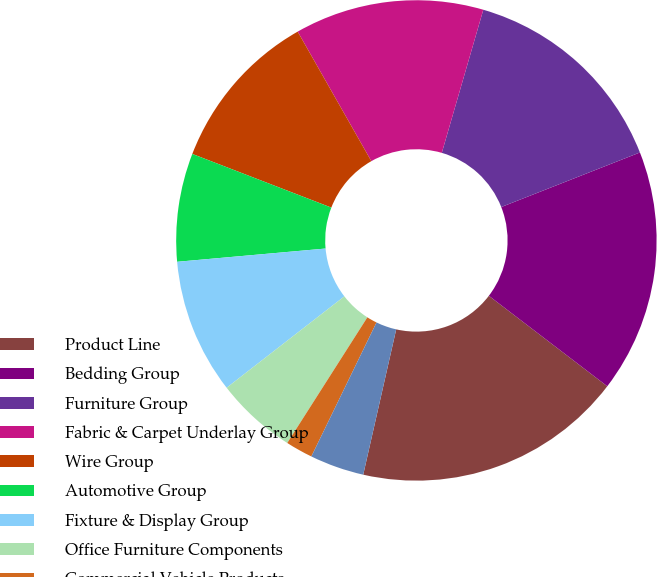Convert chart. <chart><loc_0><loc_0><loc_500><loc_500><pie_chart><fcel>Product Line<fcel>Bedding Group<fcel>Furniture Group<fcel>Fabric & Carpet Underlay Group<fcel>Wire Group<fcel>Automotive Group<fcel>Fixture & Display Group<fcel>Office Furniture Components<fcel>Commercial Vehicle Products<fcel>Machinery Group<nl><fcel>18.17%<fcel>16.35%<fcel>14.54%<fcel>12.72%<fcel>10.91%<fcel>7.28%<fcel>9.09%<fcel>5.46%<fcel>1.83%<fcel>3.65%<nl></chart> 